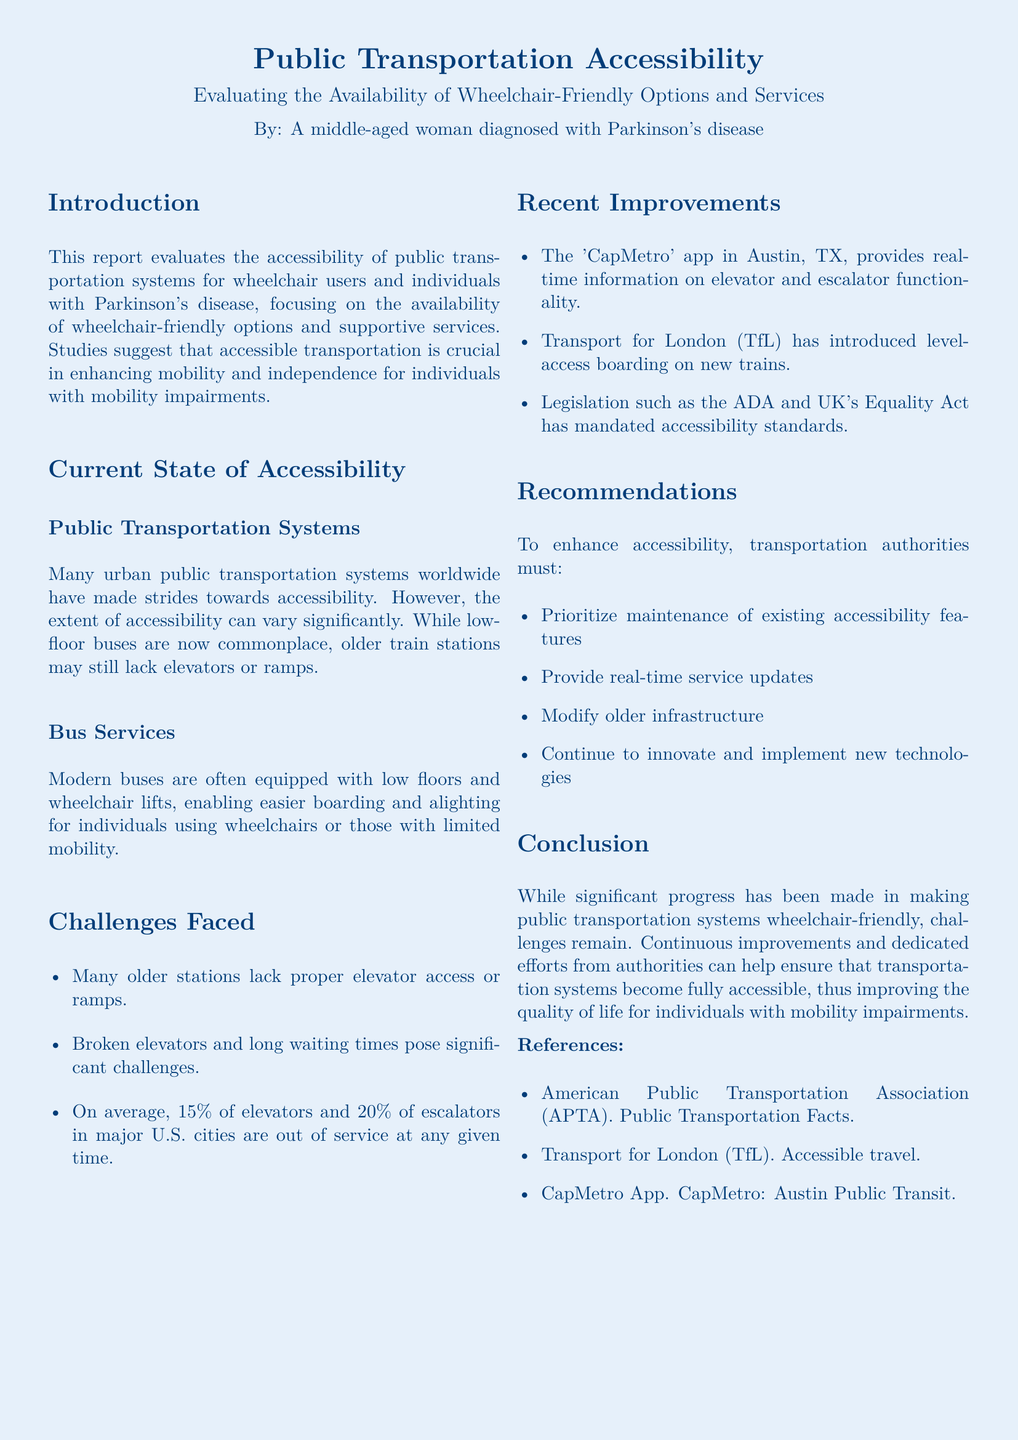What percentage of elevators are out of service in major U.S. cities? The document states that on average, 15% of elevators are out of service at any given time.
Answer: 15% What improvement did the 'CapMetro' app provide? The 'CapMetro' app offers real-time information on elevator and escalator functionality.
Answer: Real-time information What is a significant challenge mentioned for older stations? The document mentions that many older stations lack proper elevator access or ramps, which is a major challenge.
Answer: Lack of proper access Which legislation has mandated accessibility standards? The document refers to the ADA and UK's Equality Act as legislation that has mandated accessibility standards.
Answer: ADA and UK's Equality Act What is one recommendation to enhance accessibility? The report suggests prioritizing maintenance of existing accessibility features among other recommendations.
Answer: Prioritize maintenance How does Transport for London improve wheelchair access? The document states that TfL has introduced level-access boarding on new trains.
Answer: Level-access boarding What is the general state of bus services for individuals with limited mobility? The document states that modern buses are often equipped with low floors and wheelchair lifts.
Answer: Low floors and wheelchair lifts What is a notable statistic about escalators in major U.S. cities? The document states that on average, 20% of escalators in major U.S. cities are out of service at any given time.
Answer: 20% 